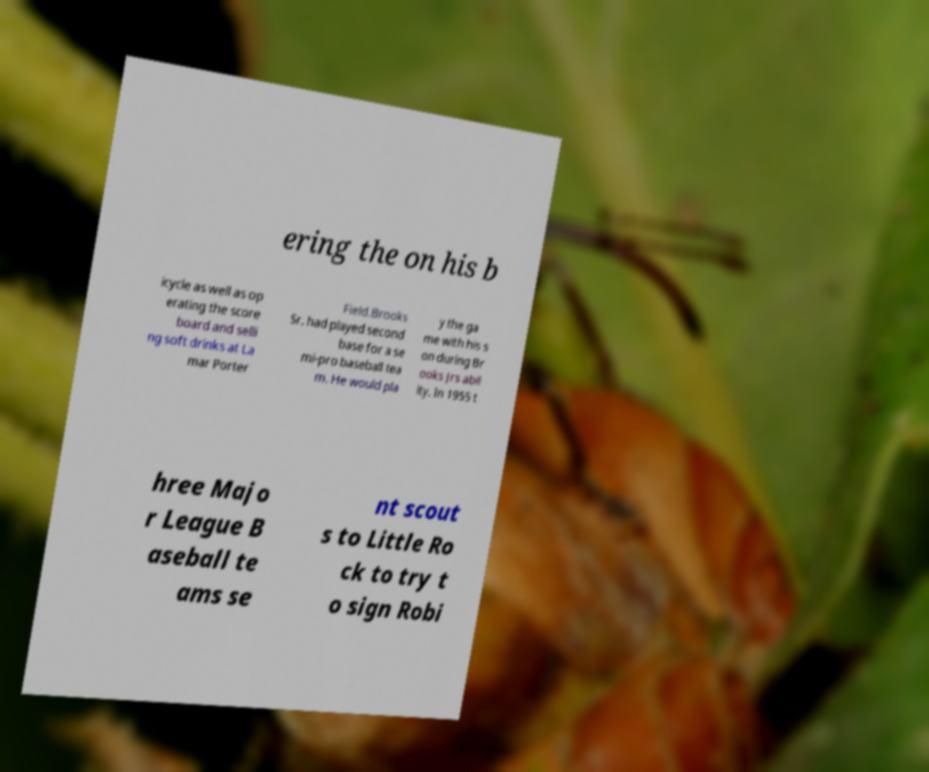I need the written content from this picture converted into text. Can you do that? ering the on his b icycle as well as op erating the score board and selli ng soft drinks at La mar Porter Field.Brooks Sr. had played second base for a se mi-pro baseball tea m. He would pla y the ga me with his s on during Br ooks Jrs abil ity. In 1955 t hree Majo r League B aseball te ams se nt scout s to Little Ro ck to try t o sign Robi 